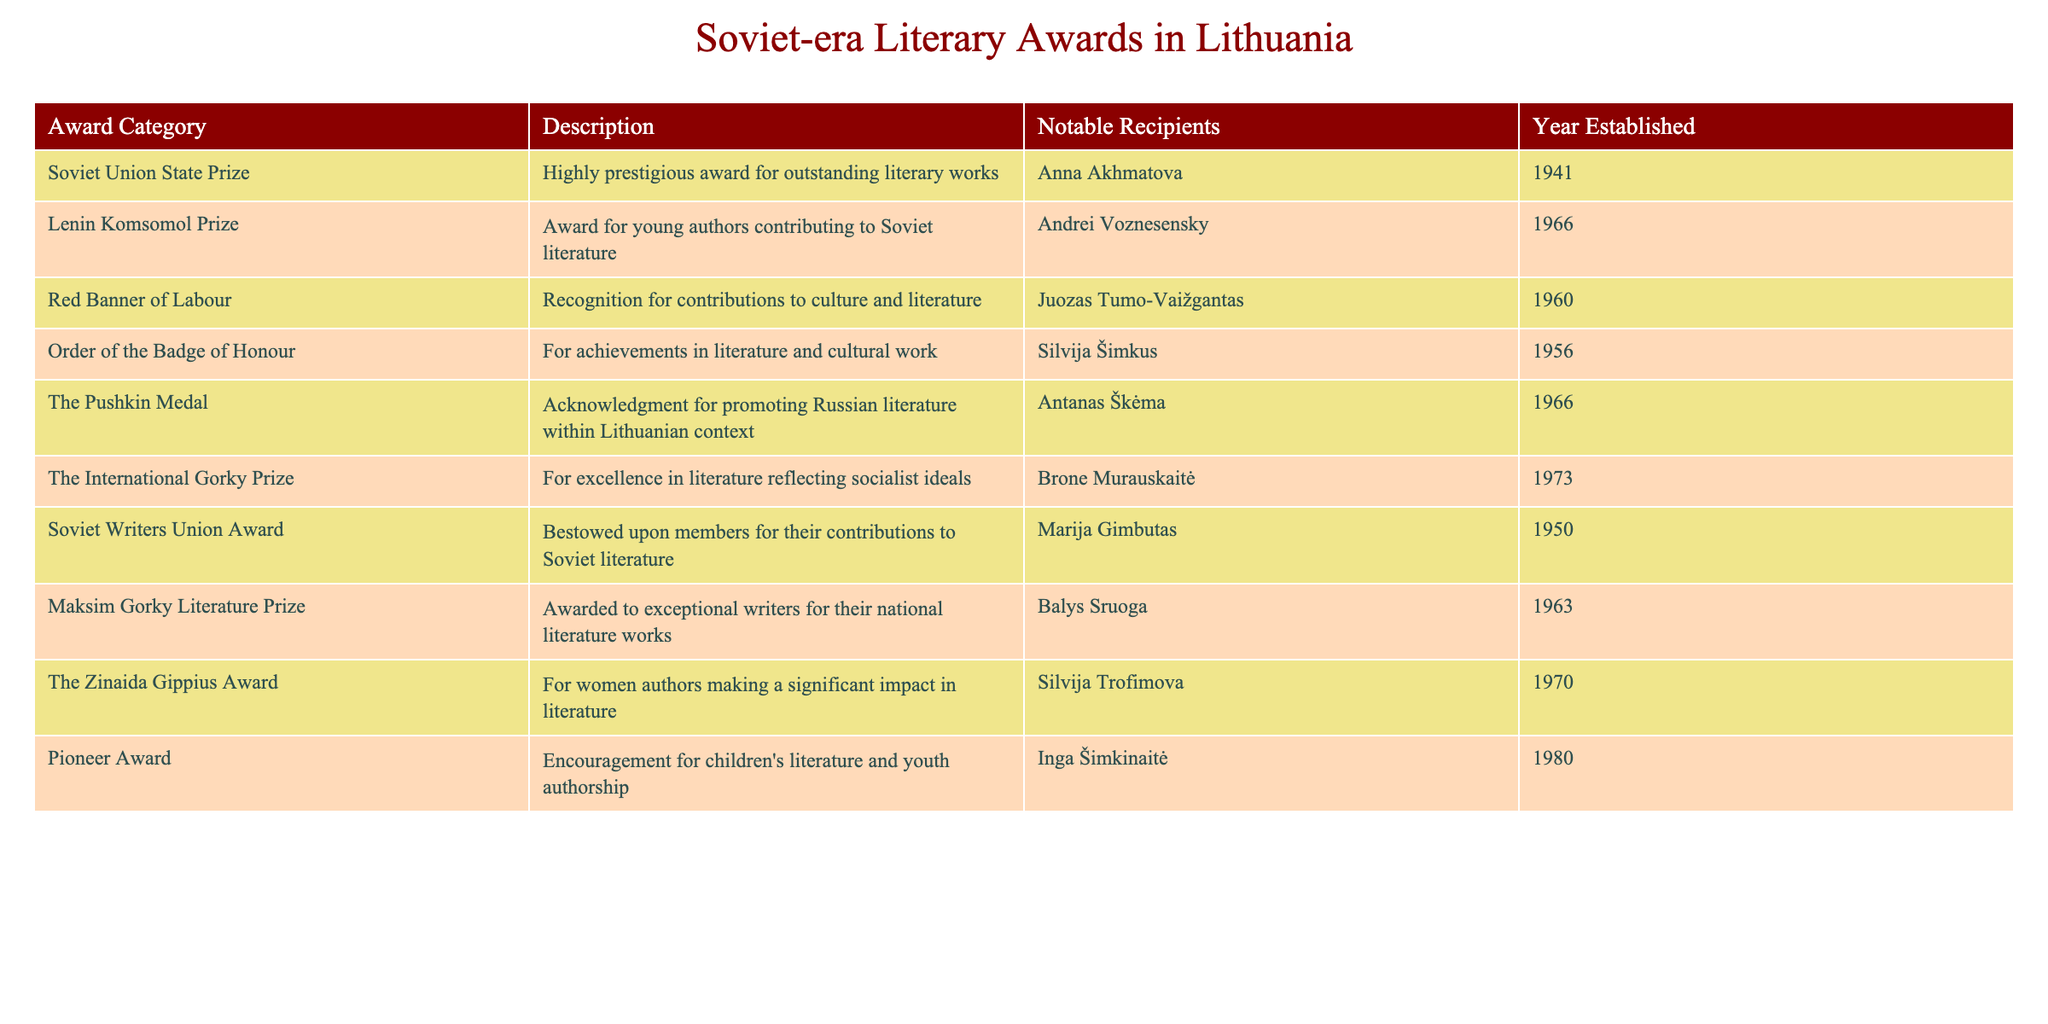What's the year when the Soviet Union State Prize was established? The table lists the year established for each award category. The Soviet Union State Prize is listed, and its corresponding year is found in the "Year Established" column.
Answer: 1941 Who received the Lenin Komsomol Prize? The table includes a column for notable recipients under each award category. For the Lenin Komsomol Prize, the notable recipient mentioned is Andrei Voznesensky.
Answer: Andrei Voznesensky Is the Order of the Badge of Honour awarded for contributions to sport? By examining the "Description" column for the Order of the Badge of Honour, it clearly specifies that it is given for achievements in literature and cultural work, not for sport.
Answer: No What is the total number of awards established by the year 1970? To find the total, I count the number of rows in the table that have a year established of 1970 or earlier. The awards with years up to 1970 are: Soviet Union State Prize (1941), Soviet Writers Union Award (1950), Order of the Badge of Honour (1956), Red Banner of Labour (1960), Lenin Komsomol Prize (1966), The Pushkin Medal (1966), Maksim Gorky Literature Prize (1963), The Zinaida Gippius Award (1970). This totals to 8 awards.
Answer: 8 Which award category recognizes contributions specifically in children's literature? The table outlines each award's focus in the "Description" column. The Pioneer Award is explicitly mentioned as encouraging children's literature and youth authorship.
Answer: Pioneer Award How many of the notable recipients are women? Analyzing the "Notable Recipients" column, I identify the female recipients: Anna Akhmatova, Silvija Šimkus, Brone Murauskaitė, Silvija Trofimova, and Marija Gimbutas, totaling 5 female recipients among the notable figures.
Answer: 5 Has the International Gorky Prize been awarded to a recipient before 1970? According to the table, the International Gorky Prize was established in 1973, which means it couldn't have been awarded to anyone before that year.
Answer: No Which award was established most recently? I review the "Year Established" column and find the maximum year, which is 1980 for the Pioneer Award. Thus, this award is the most recent.
Answer: Pioneer Award 